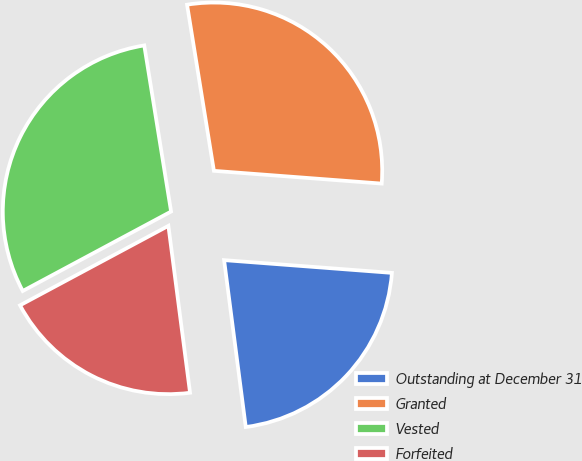Convert chart to OTSL. <chart><loc_0><loc_0><loc_500><loc_500><pie_chart><fcel>Outstanding at December 31<fcel>Granted<fcel>Vested<fcel>Forfeited<nl><fcel>21.74%<fcel>28.76%<fcel>30.28%<fcel>19.23%<nl></chart> 